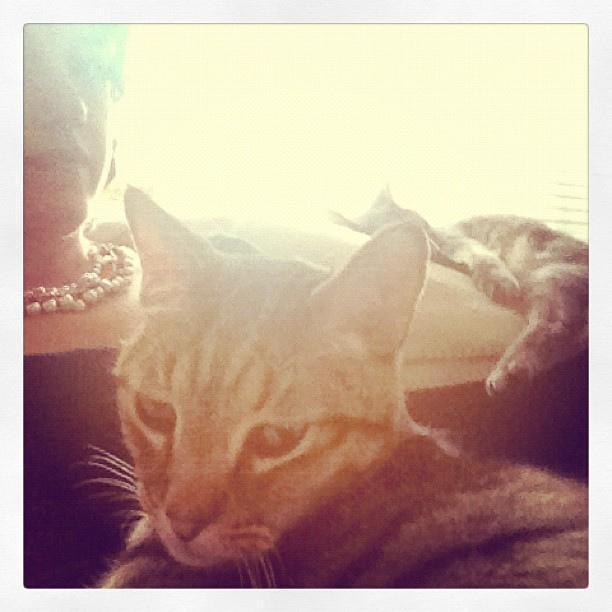How many people can you see?
Give a very brief answer. 1. 